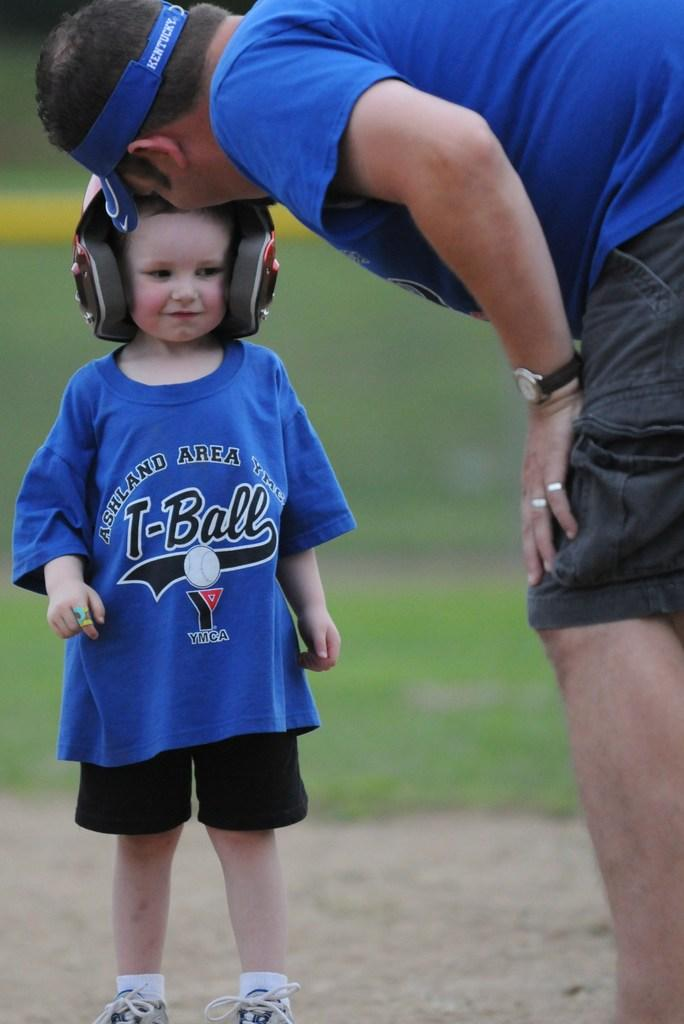<image>
Summarize the visual content of the image. Boy wearing a blue t-shirt that says T-Ball on it. 